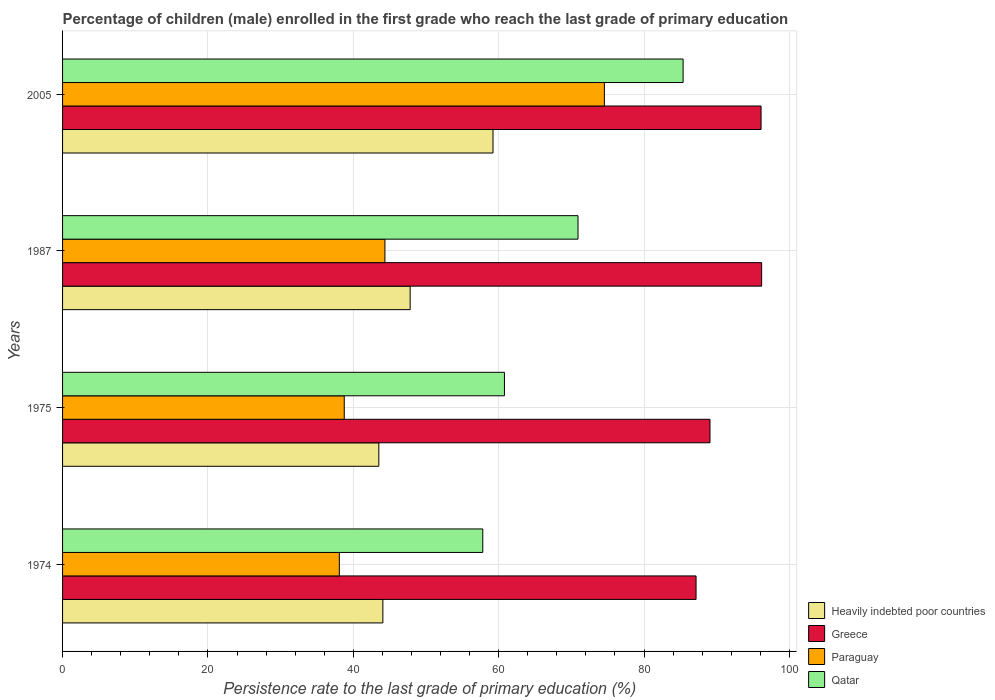How many different coloured bars are there?
Ensure brevity in your answer.  4. Are the number of bars on each tick of the Y-axis equal?
Keep it short and to the point. Yes. How many bars are there on the 4th tick from the top?
Keep it short and to the point. 4. How many bars are there on the 1st tick from the bottom?
Offer a very short reply. 4. What is the label of the 1st group of bars from the top?
Offer a terse response. 2005. What is the persistence rate of children in Heavily indebted poor countries in 1975?
Make the answer very short. 43.51. Across all years, what is the maximum persistence rate of children in Paraguay?
Give a very brief answer. 74.54. Across all years, what is the minimum persistence rate of children in Qatar?
Provide a short and direct response. 57.81. In which year was the persistence rate of children in Paraguay maximum?
Ensure brevity in your answer.  2005. In which year was the persistence rate of children in Heavily indebted poor countries minimum?
Provide a short and direct response. 1975. What is the total persistence rate of children in Greece in the graph?
Make the answer very short. 368.5. What is the difference between the persistence rate of children in Paraguay in 1974 and that in 1975?
Your answer should be very brief. -0.68. What is the difference between the persistence rate of children in Greece in 1987 and the persistence rate of children in Paraguay in 1974?
Your answer should be very brief. 58.1. What is the average persistence rate of children in Greece per year?
Your response must be concise. 92.13. In the year 2005, what is the difference between the persistence rate of children in Greece and persistence rate of children in Paraguay?
Offer a terse response. 21.55. What is the ratio of the persistence rate of children in Heavily indebted poor countries in 1974 to that in 1975?
Offer a very short reply. 1.01. Is the difference between the persistence rate of children in Greece in 1987 and 2005 greater than the difference between the persistence rate of children in Paraguay in 1987 and 2005?
Offer a terse response. Yes. What is the difference between the highest and the second highest persistence rate of children in Paraguay?
Provide a succinct answer. 30.19. What is the difference between the highest and the lowest persistence rate of children in Greece?
Your response must be concise. 9.03. In how many years, is the persistence rate of children in Qatar greater than the average persistence rate of children in Qatar taken over all years?
Your answer should be compact. 2. Is it the case that in every year, the sum of the persistence rate of children in Greece and persistence rate of children in Paraguay is greater than the sum of persistence rate of children in Qatar and persistence rate of children in Heavily indebted poor countries?
Provide a short and direct response. Yes. What does the 2nd bar from the top in 1974 represents?
Make the answer very short. Paraguay. What does the 4th bar from the bottom in 1987 represents?
Make the answer very short. Qatar. Is it the case that in every year, the sum of the persistence rate of children in Greece and persistence rate of children in Heavily indebted poor countries is greater than the persistence rate of children in Paraguay?
Your answer should be very brief. Yes. What is the difference between two consecutive major ticks on the X-axis?
Make the answer very short. 20. Are the values on the major ticks of X-axis written in scientific E-notation?
Provide a succinct answer. No. Does the graph contain any zero values?
Your answer should be very brief. No. Does the graph contain grids?
Your answer should be compact. Yes. Where does the legend appear in the graph?
Your answer should be very brief. Bottom right. What is the title of the graph?
Your response must be concise. Percentage of children (male) enrolled in the first grade who reach the last grade of primary education. Does "Venezuela" appear as one of the legend labels in the graph?
Keep it short and to the point. No. What is the label or title of the X-axis?
Give a very brief answer. Persistence rate to the last grade of primary education (%). What is the label or title of the Y-axis?
Keep it short and to the point. Years. What is the Persistence rate to the last grade of primary education (%) in Heavily indebted poor countries in 1974?
Provide a short and direct response. 44.07. What is the Persistence rate to the last grade of primary education (%) of Greece in 1974?
Your answer should be very brief. 87.15. What is the Persistence rate to the last grade of primary education (%) of Paraguay in 1974?
Provide a short and direct response. 38.08. What is the Persistence rate to the last grade of primary education (%) in Qatar in 1974?
Your response must be concise. 57.81. What is the Persistence rate to the last grade of primary education (%) in Heavily indebted poor countries in 1975?
Keep it short and to the point. 43.51. What is the Persistence rate to the last grade of primary education (%) of Greece in 1975?
Offer a terse response. 89.07. What is the Persistence rate to the last grade of primary education (%) of Paraguay in 1975?
Your response must be concise. 38.75. What is the Persistence rate to the last grade of primary education (%) of Qatar in 1975?
Provide a short and direct response. 60.79. What is the Persistence rate to the last grade of primary education (%) of Heavily indebted poor countries in 1987?
Offer a terse response. 47.82. What is the Persistence rate to the last grade of primary education (%) of Greece in 1987?
Ensure brevity in your answer.  96.18. What is the Persistence rate to the last grade of primary education (%) in Paraguay in 1987?
Keep it short and to the point. 44.35. What is the Persistence rate to the last grade of primary education (%) of Qatar in 1987?
Your response must be concise. 70.91. What is the Persistence rate to the last grade of primary education (%) of Heavily indebted poor countries in 2005?
Keep it short and to the point. 59.22. What is the Persistence rate to the last grade of primary education (%) of Greece in 2005?
Keep it short and to the point. 96.1. What is the Persistence rate to the last grade of primary education (%) in Paraguay in 2005?
Provide a succinct answer. 74.54. What is the Persistence rate to the last grade of primary education (%) of Qatar in 2005?
Keep it short and to the point. 85.37. Across all years, what is the maximum Persistence rate to the last grade of primary education (%) of Heavily indebted poor countries?
Make the answer very short. 59.22. Across all years, what is the maximum Persistence rate to the last grade of primary education (%) in Greece?
Provide a short and direct response. 96.18. Across all years, what is the maximum Persistence rate to the last grade of primary education (%) in Paraguay?
Your answer should be compact. 74.54. Across all years, what is the maximum Persistence rate to the last grade of primary education (%) in Qatar?
Provide a succinct answer. 85.37. Across all years, what is the minimum Persistence rate to the last grade of primary education (%) in Heavily indebted poor countries?
Provide a succinct answer. 43.51. Across all years, what is the minimum Persistence rate to the last grade of primary education (%) of Greece?
Your answer should be compact. 87.15. Across all years, what is the minimum Persistence rate to the last grade of primary education (%) of Paraguay?
Ensure brevity in your answer.  38.08. Across all years, what is the minimum Persistence rate to the last grade of primary education (%) of Qatar?
Your response must be concise. 57.81. What is the total Persistence rate to the last grade of primary education (%) in Heavily indebted poor countries in the graph?
Ensure brevity in your answer.  194.62. What is the total Persistence rate to the last grade of primary education (%) in Greece in the graph?
Provide a short and direct response. 368.5. What is the total Persistence rate to the last grade of primary education (%) of Paraguay in the graph?
Offer a terse response. 195.72. What is the total Persistence rate to the last grade of primary education (%) in Qatar in the graph?
Give a very brief answer. 274.89. What is the difference between the Persistence rate to the last grade of primary education (%) of Heavily indebted poor countries in 1974 and that in 1975?
Offer a very short reply. 0.56. What is the difference between the Persistence rate to the last grade of primary education (%) of Greece in 1974 and that in 1975?
Your answer should be very brief. -1.92. What is the difference between the Persistence rate to the last grade of primary education (%) of Paraguay in 1974 and that in 1975?
Offer a terse response. -0.68. What is the difference between the Persistence rate to the last grade of primary education (%) of Qatar in 1974 and that in 1975?
Make the answer very short. -2.98. What is the difference between the Persistence rate to the last grade of primary education (%) in Heavily indebted poor countries in 1974 and that in 1987?
Make the answer very short. -3.75. What is the difference between the Persistence rate to the last grade of primary education (%) of Greece in 1974 and that in 1987?
Make the answer very short. -9.03. What is the difference between the Persistence rate to the last grade of primary education (%) of Paraguay in 1974 and that in 1987?
Give a very brief answer. -6.27. What is the difference between the Persistence rate to the last grade of primary education (%) in Qatar in 1974 and that in 1987?
Your response must be concise. -13.1. What is the difference between the Persistence rate to the last grade of primary education (%) in Heavily indebted poor countries in 1974 and that in 2005?
Provide a succinct answer. -15.15. What is the difference between the Persistence rate to the last grade of primary education (%) of Greece in 1974 and that in 2005?
Make the answer very short. -8.94. What is the difference between the Persistence rate to the last grade of primary education (%) in Paraguay in 1974 and that in 2005?
Offer a very short reply. -36.47. What is the difference between the Persistence rate to the last grade of primary education (%) in Qatar in 1974 and that in 2005?
Your response must be concise. -27.56. What is the difference between the Persistence rate to the last grade of primary education (%) in Heavily indebted poor countries in 1975 and that in 1987?
Your response must be concise. -4.31. What is the difference between the Persistence rate to the last grade of primary education (%) of Greece in 1975 and that in 1987?
Your response must be concise. -7.11. What is the difference between the Persistence rate to the last grade of primary education (%) of Paraguay in 1975 and that in 1987?
Provide a short and direct response. -5.6. What is the difference between the Persistence rate to the last grade of primary education (%) of Qatar in 1975 and that in 1987?
Provide a short and direct response. -10.12. What is the difference between the Persistence rate to the last grade of primary education (%) in Heavily indebted poor countries in 1975 and that in 2005?
Give a very brief answer. -15.71. What is the difference between the Persistence rate to the last grade of primary education (%) of Greece in 1975 and that in 2005?
Your response must be concise. -7.03. What is the difference between the Persistence rate to the last grade of primary education (%) in Paraguay in 1975 and that in 2005?
Offer a terse response. -35.79. What is the difference between the Persistence rate to the last grade of primary education (%) of Qatar in 1975 and that in 2005?
Your answer should be very brief. -24.58. What is the difference between the Persistence rate to the last grade of primary education (%) in Heavily indebted poor countries in 1987 and that in 2005?
Your answer should be very brief. -11.4. What is the difference between the Persistence rate to the last grade of primary education (%) of Greece in 1987 and that in 2005?
Provide a succinct answer. 0.08. What is the difference between the Persistence rate to the last grade of primary education (%) in Paraguay in 1987 and that in 2005?
Your answer should be compact. -30.19. What is the difference between the Persistence rate to the last grade of primary education (%) of Qatar in 1987 and that in 2005?
Give a very brief answer. -14.46. What is the difference between the Persistence rate to the last grade of primary education (%) in Heavily indebted poor countries in 1974 and the Persistence rate to the last grade of primary education (%) in Greece in 1975?
Ensure brevity in your answer.  -45. What is the difference between the Persistence rate to the last grade of primary education (%) in Heavily indebted poor countries in 1974 and the Persistence rate to the last grade of primary education (%) in Paraguay in 1975?
Your response must be concise. 5.31. What is the difference between the Persistence rate to the last grade of primary education (%) of Heavily indebted poor countries in 1974 and the Persistence rate to the last grade of primary education (%) of Qatar in 1975?
Make the answer very short. -16.73. What is the difference between the Persistence rate to the last grade of primary education (%) of Greece in 1974 and the Persistence rate to the last grade of primary education (%) of Paraguay in 1975?
Offer a terse response. 48.4. What is the difference between the Persistence rate to the last grade of primary education (%) in Greece in 1974 and the Persistence rate to the last grade of primary education (%) in Qatar in 1975?
Make the answer very short. 26.36. What is the difference between the Persistence rate to the last grade of primary education (%) in Paraguay in 1974 and the Persistence rate to the last grade of primary education (%) in Qatar in 1975?
Your answer should be very brief. -22.72. What is the difference between the Persistence rate to the last grade of primary education (%) in Heavily indebted poor countries in 1974 and the Persistence rate to the last grade of primary education (%) in Greece in 1987?
Offer a very short reply. -52.11. What is the difference between the Persistence rate to the last grade of primary education (%) in Heavily indebted poor countries in 1974 and the Persistence rate to the last grade of primary education (%) in Paraguay in 1987?
Make the answer very short. -0.28. What is the difference between the Persistence rate to the last grade of primary education (%) in Heavily indebted poor countries in 1974 and the Persistence rate to the last grade of primary education (%) in Qatar in 1987?
Your answer should be very brief. -26.85. What is the difference between the Persistence rate to the last grade of primary education (%) in Greece in 1974 and the Persistence rate to the last grade of primary education (%) in Paraguay in 1987?
Ensure brevity in your answer.  42.8. What is the difference between the Persistence rate to the last grade of primary education (%) of Greece in 1974 and the Persistence rate to the last grade of primary education (%) of Qatar in 1987?
Provide a short and direct response. 16.24. What is the difference between the Persistence rate to the last grade of primary education (%) in Paraguay in 1974 and the Persistence rate to the last grade of primary education (%) in Qatar in 1987?
Provide a short and direct response. -32.84. What is the difference between the Persistence rate to the last grade of primary education (%) of Heavily indebted poor countries in 1974 and the Persistence rate to the last grade of primary education (%) of Greece in 2005?
Ensure brevity in your answer.  -52.03. What is the difference between the Persistence rate to the last grade of primary education (%) of Heavily indebted poor countries in 1974 and the Persistence rate to the last grade of primary education (%) of Paraguay in 2005?
Provide a succinct answer. -30.48. What is the difference between the Persistence rate to the last grade of primary education (%) in Heavily indebted poor countries in 1974 and the Persistence rate to the last grade of primary education (%) in Qatar in 2005?
Offer a terse response. -41.31. What is the difference between the Persistence rate to the last grade of primary education (%) in Greece in 1974 and the Persistence rate to the last grade of primary education (%) in Paraguay in 2005?
Provide a short and direct response. 12.61. What is the difference between the Persistence rate to the last grade of primary education (%) of Greece in 1974 and the Persistence rate to the last grade of primary education (%) of Qatar in 2005?
Your response must be concise. 1.78. What is the difference between the Persistence rate to the last grade of primary education (%) in Paraguay in 1974 and the Persistence rate to the last grade of primary education (%) in Qatar in 2005?
Your answer should be compact. -47.3. What is the difference between the Persistence rate to the last grade of primary education (%) in Heavily indebted poor countries in 1975 and the Persistence rate to the last grade of primary education (%) in Greece in 1987?
Offer a very short reply. -52.67. What is the difference between the Persistence rate to the last grade of primary education (%) of Heavily indebted poor countries in 1975 and the Persistence rate to the last grade of primary education (%) of Paraguay in 1987?
Offer a terse response. -0.84. What is the difference between the Persistence rate to the last grade of primary education (%) in Heavily indebted poor countries in 1975 and the Persistence rate to the last grade of primary education (%) in Qatar in 1987?
Provide a succinct answer. -27.4. What is the difference between the Persistence rate to the last grade of primary education (%) of Greece in 1975 and the Persistence rate to the last grade of primary education (%) of Paraguay in 1987?
Offer a terse response. 44.72. What is the difference between the Persistence rate to the last grade of primary education (%) of Greece in 1975 and the Persistence rate to the last grade of primary education (%) of Qatar in 1987?
Give a very brief answer. 18.16. What is the difference between the Persistence rate to the last grade of primary education (%) in Paraguay in 1975 and the Persistence rate to the last grade of primary education (%) in Qatar in 1987?
Offer a terse response. -32.16. What is the difference between the Persistence rate to the last grade of primary education (%) in Heavily indebted poor countries in 1975 and the Persistence rate to the last grade of primary education (%) in Greece in 2005?
Offer a terse response. -52.59. What is the difference between the Persistence rate to the last grade of primary education (%) of Heavily indebted poor countries in 1975 and the Persistence rate to the last grade of primary education (%) of Paraguay in 2005?
Give a very brief answer. -31.03. What is the difference between the Persistence rate to the last grade of primary education (%) in Heavily indebted poor countries in 1975 and the Persistence rate to the last grade of primary education (%) in Qatar in 2005?
Provide a short and direct response. -41.86. What is the difference between the Persistence rate to the last grade of primary education (%) of Greece in 1975 and the Persistence rate to the last grade of primary education (%) of Paraguay in 2005?
Offer a terse response. 14.53. What is the difference between the Persistence rate to the last grade of primary education (%) of Greece in 1975 and the Persistence rate to the last grade of primary education (%) of Qatar in 2005?
Ensure brevity in your answer.  3.7. What is the difference between the Persistence rate to the last grade of primary education (%) of Paraguay in 1975 and the Persistence rate to the last grade of primary education (%) of Qatar in 2005?
Offer a terse response. -46.62. What is the difference between the Persistence rate to the last grade of primary education (%) of Heavily indebted poor countries in 1987 and the Persistence rate to the last grade of primary education (%) of Greece in 2005?
Your response must be concise. -48.28. What is the difference between the Persistence rate to the last grade of primary education (%) of Heavily indebted poor countries in 1987 and the Persistence rate to the last grade of primary education (%) of Paraguay in 2005?
Your answer should be very brief. -26.72. What is the difference between the Persistence rate to the last grade of primary education (%) in Heavily indebted poor countries in 1987 and the Persistence rate to the last grade of primary education (%) in Qatar in 2005?
Offer a terse response. -37.55. What is the difference between the Persistence rate to the last grade of primary education (%) in Greece in 1987 and the Persistence rate to the last grade of primary education (%) in Paraguay in 2005?
Ensure brevity in your answer.  21.64. What is the difference between the Persistence rate to the last grade of primary education (%) of Greece in 1987 and the Persistence rate to the last grade of primary education (%) of Qatar in 2005?
Keep it short and to the point. 10.81. What is the difference between the Persistence rate to the last grade of primary education (%) in Paraguay in 1987 and the Persistence rate to the last grade of primary education (%) in Qatar in 2005?
Offer a terse response. -41.02. What is the average Persistence rate to the last grade of primary education (%) in Heavily indebted poor countries per year?
Provide a short and direct response. 48.65. What is the average Persistence rate to the last grade of primary education (%) in Greece per year?
Your response must be concise. 92.13. What is the average Persistence rate to the last grade of primary education (%) of Paraguay per year?
Offer a very short reply. 48.93. What is the average Persistence rate to the last grade of primary education (%) of Qatar per year?
Provide a short and direct response. 68.72. In the year 1974, what is the difference between the Persistence rate to the last grade of primary education (%) in Heavily indebted poor countries and Persistence rate to the last grade of primary education (%) in Greece?
Provide a short and direct response. -43.09. In the year 1974, what is the difference between the Persistence rate to the last grade of primary education (%) of Heavily indebted poor countries and Persistence rate to the last grade of primary education (%) of Paraguay?
Keep it short and to the point. 5.99. In the year 1974, what is the difference between the Persistence rate to the last grade of primary education (%) of Heavily indebted poor countries and Persistence rate to the last grade of primary education (%) of Qatar?
Your response must be concise. -13.74. In the year 1974, what is the difference between the Persistence rate to the last grade of primary education (%) of Greece and Persistence rate to the last grade of primary education (%) of Paraguay?
Your response must be concise. 49.08. In the year 1974, what is the difference between the Persistence rate to the last grade of primary education (%) of Greece and Persistence rate to the last grade of primary education (%) of Qatar?
Offer a terse response. 29.34. In the year 1974, what is the difference between the Persistence rate to the last grade of primary education (%) of Paraguay and Persistence rate to the last grade of primary education (%) of Qatar?
Keep it short and to the point. -19.74. In the year 1975, what is the difference between the Persistence rate to the last grade of primary education (%) in Heavily indebted poor countries and Persistence rate to the last grade of primary education (%) in Greece?
Provide a succinct answer. -45.56. In the year 1975, what is the difference between the Persistence rate to the last grade of primary education (%) in Heavily indebted poor countries and Persistence rate to the last grade of primary education (%) in Paraguay?
Provide a short and direct response. 4.76. In the year 1975, what is the difference between the Persistence rate to the last grade of primary education (%) in Heavily indebted poor countries and Persistence rate to the last grade of primary education (%) in Qatar?
Offer a terse response. -17.28. In the year 1975, what is the difference between the Persistence rate to the last grade of primary education (%) of Greece and Persistence rate to the last grade of primary education (%) of Paraguay?
Your response must be concise. 50.32. In the year 1975, what is the difference between the Persistence rate to the last grade of primary education (%) of Greece and Persistence rate to the last grade of primary education (%) of Qatar?
Ensure brevity in your answer.  28.28. In the year 1975, what is the difference between the Persistence rate to the last grade of primary education (%) of Paraguay and Persistence rate to the last grade of primary education (%) of Qatar?
Give a very brief answer. -22.04. In the year 1987, what is the difference between the Persistence rate to the last grade of primary education (%) in Heavily indebted poor countries and Persistence rate to the last grade of primary education (%) in Greece?
Make the answer very short. -48.36. In the year 1987, what is the difference between the Persistence rate to the last grade of primary education (%) of Heavily indebted poor countries and Persistence rate to the last grade of primary education (%) of Paraguay?
Make the answer very short. 3.47. In the year 1987, what is the difference between the Persistence rate to the last grade of primary education (%) in Heavily indebted poor countries and Persistence rate to the last grade of primary education (%) in Qatar?
Your answer should be compact. -23.09. In the year 1987, what is the difference between the Persistence rate to the last grade of primary education (%) of Greece and Persistence rate to the last grade of primary education (%) of Paraguay?
Provide a succinct answer. 51.83. In the year 1987, what is the difference between the Persistence rate to the last grade of primary education (%) in Greece and Persistence rate to the last grade of primary education (%) in Qatar?
Keep it short and to the point. 25.27. In the year 1987, what is the difference between the Persistence rate to the last grade of primary education (%) in Paraguay and Persistence rate to the last grade of primary education (%) in Qatar?
Provide a succinct answer. -26.57. In the year 2005, what is the difference between the Persistence rate to the last grade of primary education (%) in Heavily indebted poor countries and Persistence rate to the last grade of primary education (%) in Greece?
Offer a terse response. -36.88. In the year 2005, what is the difference between the Persistence rate to the last grade of primary education (%) in Heavily indebted poor countries and Persistence rate to the last grade of primary education (%) in Paraguay?
Give a very brief answer. -15.32. In the year 2005, what is the difference between the Persistence rate to the last grade of primary education (%) of Heavily indebted poor countries and Persistence rate to the last grade of primary education (%) of Qatar?
Make the answer very short. -26.15. In the year 2005, what is the difference between the Persistence rate to the last grade of primary education (%) in Greece and Persistence rate to the last grade of primary education (%) in Paraguay?
Offer a very short reply. 21.55. In the year 2005, what is the difference between the Persistence rate to the last grade of primary education (%) of Greece and Persistence rate to the last grade of primary education (%) of Qatar?
Offer a very short reply. 10.73. In the year 2005, what is the difference between the Persistence rate to the last grade of primary education (%) in Paraguay and Persistence rate to the last grade of primary education (%) in Qatar?
Your response must be concise. -10.83. What is the ratio of the Persistence rate to the last grade of primary education (%) in Heavily indebted poor countries in 1974 to that in 1975?
Give a very brief answer. 1.01. What is the ratio of the Persistence rate to the last grade of primary education (%) of Greece in 1974 to that in 1975?
Your answer should be very brief. 0.98. What is the ratio of the Persistence rate to the last grade of primary education (%) in Paraguay in 1974 to that in 1975?
Offer a very short reply. 0.98. What is the ratio of the Persistence rate to the last grade of primary education (%) in Qatar in 1974 to that in 1975?
Give a very brief answer. 0.95. What is the ratio of the Persistence rate to the last grade of primary education (%) of Heavily indebted poor countries in 1974 to that in 1987?
Keep it short and to the point. 0.92. What is the ratio of the Persistence rate to the last grade of primary education (%) in Greece in 1974 to that in 1987?
Provide a short and direct response. 0.91. What is the ratio of the Persistence rate to the last grade of primary education (%) of Paraguay in 1974 to that in 1987?
Offer a very short reply. 0.86. What is the ratio of the Persistence rate to the last grade of primary education (%) of Qatar in 1974 to that in 1987?
Your answer should be compact. 0.82. What is the ratio of the Persistence rate to the last grade of primary education (%) in Heavily indebted poor countries in 1974 to that in 2005?
Offer a very short reply. 0.74. What is the ratio of the Persistence rate to the last grade of primary education (%) in Greece in 1974 to that in 2005?
Provide a succinct answer. 0.91. What is the ratio of the Persistence rate to the last grade of primary education (%) of Paraguay in 1974 to that in 2005?
Offer a terse response. 0.51. What is the ratio of the Persistence rate to the last grade of primary education (%) in Qatar in 1974 to that in 2005?
Offer a terse response. 0.68. What is the ratio of the Persistence rate to the last grade of primary education (%) of Heavily indebted poor countries in 1975 to that in 1987?
Ensure brevity in your answer.  0.91. What is the ratio of the Persistence rate to the last grade of primary education (%) of Greece in 1975 to that in 1987?
Your answer should be very brief. 0.93. What is the ratio of the Persistence rate to the last grade of primary education (%) of Paraguay in 1975 to that in 1987?
Provide a short and direct response. 0.87. What is the ratio of the Persistence rate to the last grade of primary education (%) of Qatar in 1975 to that in 1987?
Keep it short and to the point. 0.86. What is the ratio of the Persistence rate to the last grade of primary education (%) in Heavily indebted poor countries in 1975 to that in 2005?
Give a very brief answer. 0.73. What is the ratio of the Persistence rate to the last grade of primary education (%) in Greece in 1975 to that in 2005?
Keep it short and to the point. 0.93. What is the ratio of the Persistence rate to the last grade of primary education (%) of Paraguay in 1975 to that in 2005?
Make the answer very short. 0.52. What is the ratio of the Persistence rate to the last grade of primary education (%) of Qatar in 1975 to that in 2005?
Offer a very short reply. 0.71. What is the ratio of the Persistence rate to the last grade of primary education (%) of Heavily indebted poor countries in 1987 to that in 2005?
Your answer should be very brief. 0.81. What is the ratio of the Persistence rate to the last grade of primary education (%) of Greece in 1987 to that in 2005?
Ensure brevity in your answer.  1. What is the ratio of the Persistence rate to the last grade of primary education (%) in Paraguay in 1987 to that in 2005?
Your answer should be very brief. 0.59. What is the ratio of the Persistence rate to the last grade of primary education (%) of Qatar in 1987 to that in 2005?
Make the answer very short. 0.83. What is the difference between the highest and the second highest Persistence rate to the last grade of primary education (%) in Heavily indebted poor countries?
Provide a succinct answer. 11.4. What is the difference between the highest and the second highest Persistence rate to the last grade of primary education (%) of Greece?
Keep it short and to the point. 0.08. What is the difference between the highest and the second highest Persistence rate to the last grade of primary education (%) in Paraguay?
Make the answer very short. 30.19. What is the difference between the highest and the second highest Persistence rate to the last grade of primary education (%) of Qatar?
Make the answer very short. 14.46. What is the difference between the highest and the lowest Persistence rate to the last grade of primary education (%) of Heavily indebted poor countries?
Make the answer very short. 15.71. What is the difference between the highest and the lowest Persistence rate to the last grade of primary education (%) in Greece?
Provide a succinct answer. 9.03. What is the difference between the highest and the lowest Persistence rate to the last grade of primary education (%) in Paraguay?
Give a very brief answer. 36.47. What is the difference between the highest and the lowest Persistence rate to the last grade of primary education (%) in Qatar?
Keep it short and to the point. 27.56. 